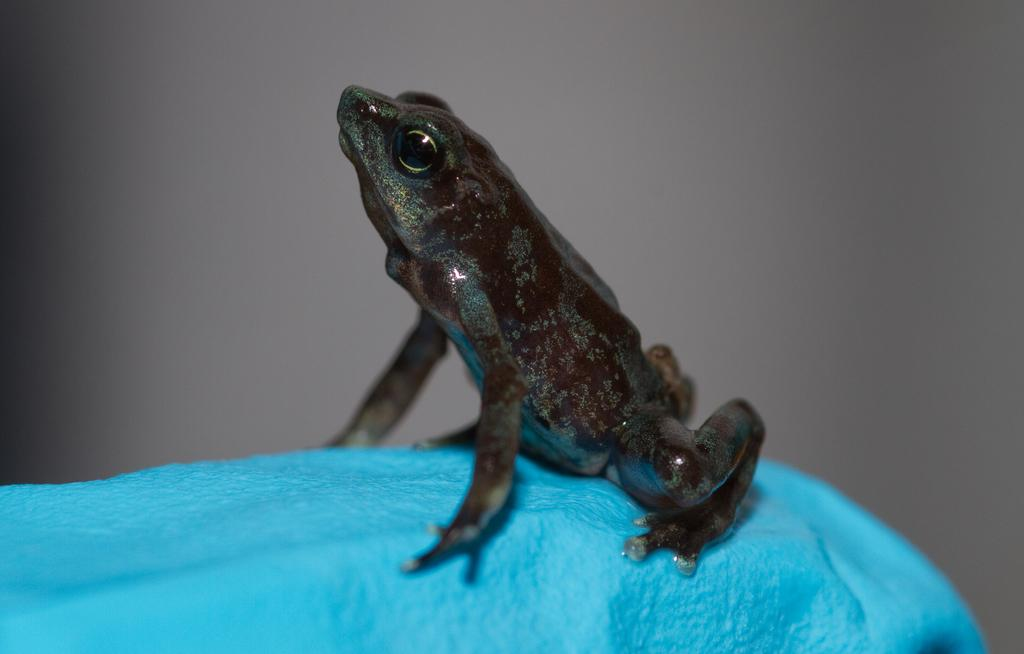What is the main subject in the center of the image? There is a frog in the center of the image. What type of tiger can be seen in the image? There is no tiger present in the image; it features a frog. How many lines are visible in the image? The provided facts do not mention any lines in the image, so it is impossible to determine the number of lines. 